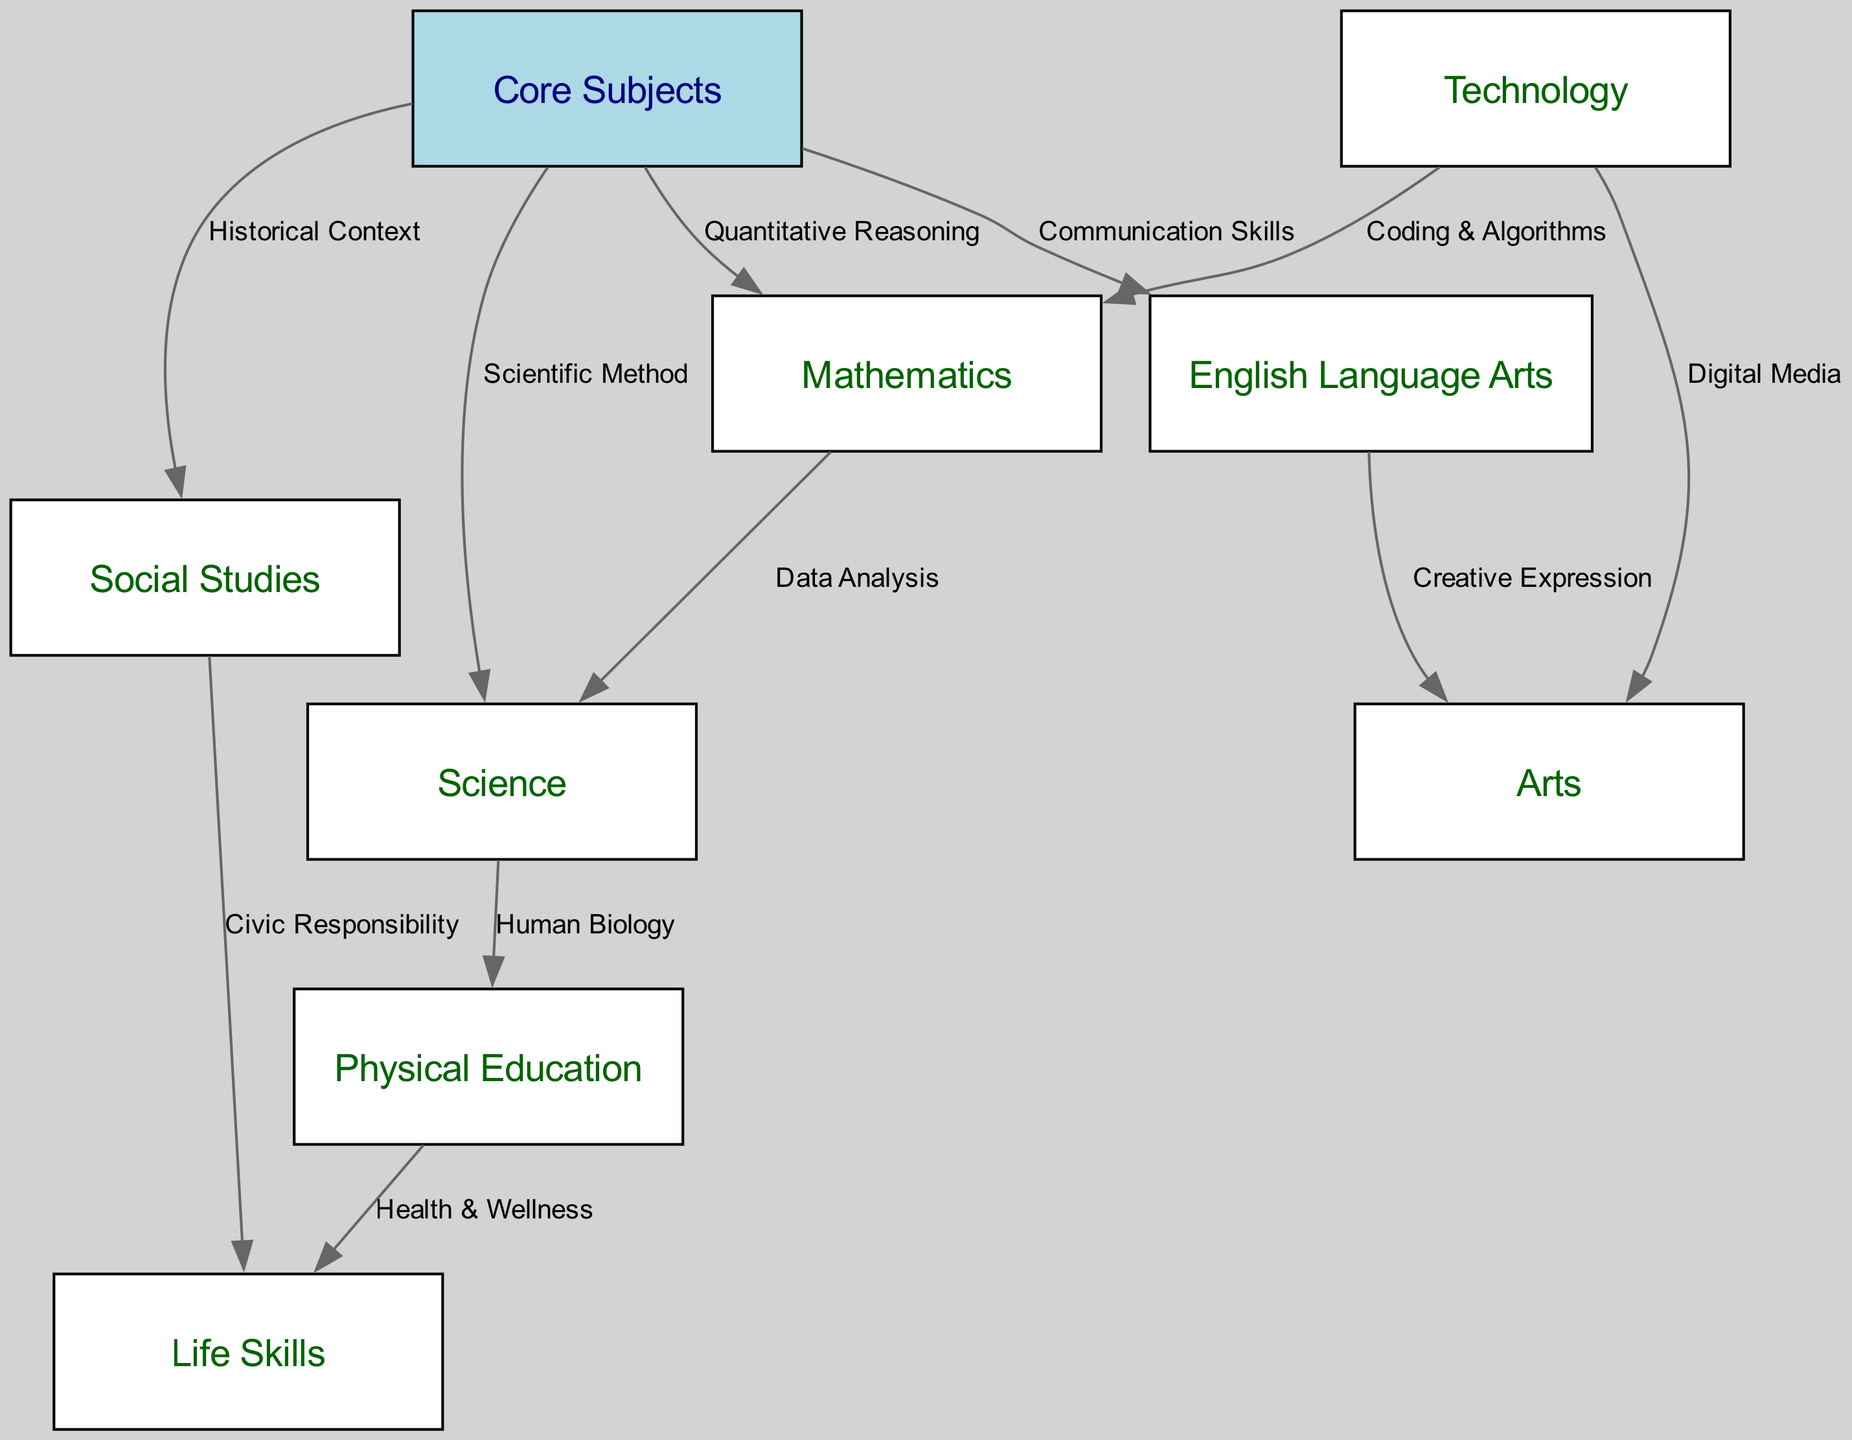What are the core subjects in the curriculum? The core subjects are represented as nodes connected to the "Core Subjects" node. The nodes displayed are Mathematics, Science, English Language Arts, Social Studies, Physical Education, Arts, Technology, and Life Skills. These nodes indicate the key areas of study in the curriculum.
Answer: Mathematics, Science, English Language Arts, Social Studies, Physical Education, Arts, Technology, Life Skills How many subjects are connected to core subjects? The "Core Subjects" node is connected to eight other subject nodes: Mathematics, Science, English Language Arts, Social Studies, Physical Education, Arts, Technology, and Life Skills, indicating the foundational areas of the curriculum.
Answer: Eight Which subject connects to Physical Education? To find the subject connected to Physical Education, I trace the edge that leads out from the Physical Education node. The diagram shows that it connects to Life Skills via the label "Health & Wellness."
Answer: Life Skills What interdisciplinary connection exists between Mathematics and Science? The connection between Mathematics and Science is indicated by an edge labeled "Data Analysis." This signifies that Mathematics supports the understanding and application within Science through quantitative analysis methods.
Answer: Data Analysis Which subjects provide skills in communication? To find subjects related to communication skills, I look for edges leading from the English Language Arts node. The edge maps out the connection between English Language Arts and Arts through "Creative Expression," highlighting how communication skills apply in the context of arts.
Answer: Arts What does Technology connect to in Mathematics? Technology has an edge leading to Mathematics, labeled "Coding & Algorithms." This shows the relationship where technology interlinks with mathematics based on coding principles and algorithm design, essential for problem-solving.
Answer: Coding & Algorithms What unique relationship exists between Social Studies and Life Skills? The relationship shows that Social Studies connects to Life Skills through the edge labeled "Civic Responsibility." This indicates that understanding social studies is integral to developing responsible citizenship skills linked to life skills.
Answer: Civic Responsibility What does Science connect to in terms of Physical Education? There is a connection from Science to Physical Education depicted in the diagram, labeled "Human Biology." This connection emphasizes the scientific principles that underlie lessons in physical education, particularly related to human health and performance.
Answer: Human Biology How many unique edges are connecting Core Subjects to other subjects? The Core Subjects node connects to four subjects outlined in the diagram, leading to Mathematics, Science, English Language Arts, and Social Studies with a total of four unique edges.
Answer: Four 